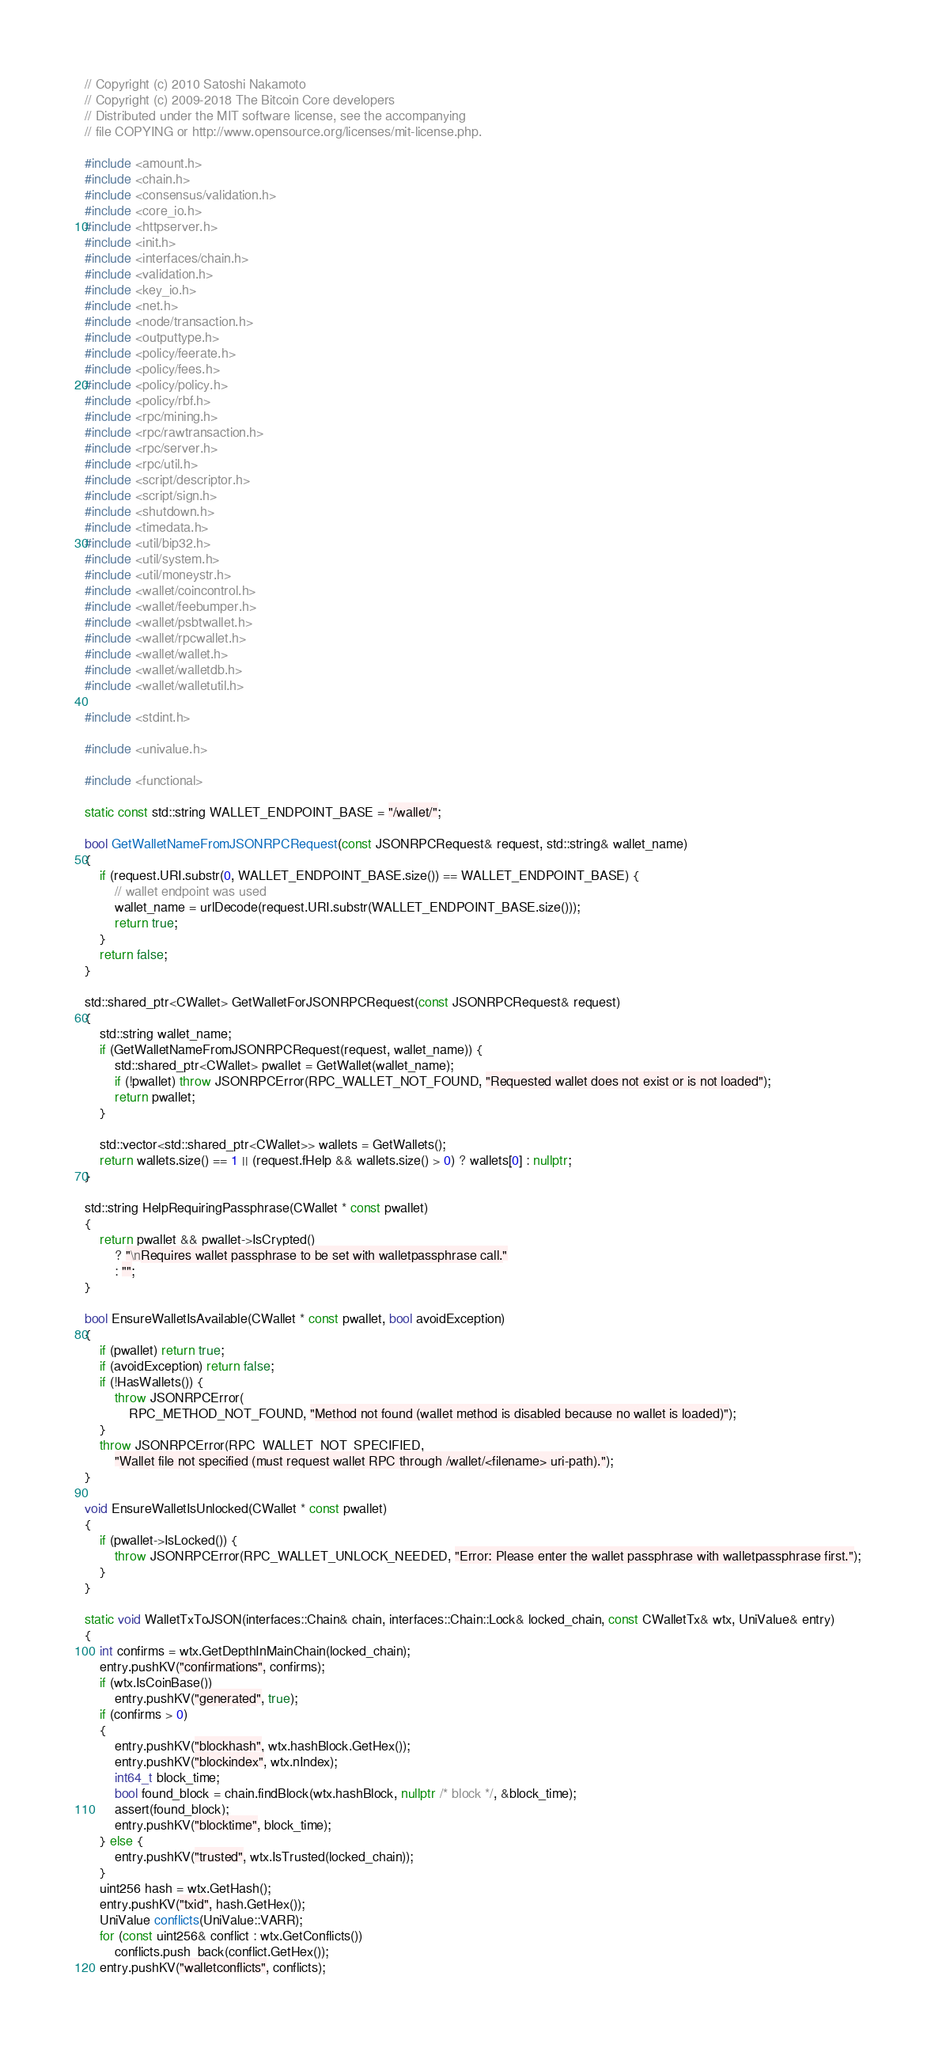Convert code to text. <code><loc_0><loc_0><loc_500><loc_500><_C++_>// Copyright (c) 2010 Satoshi Nakamoto
// Copyright (c) 2009-2018 The Bitcoin Core developers
// Distributed under the MIT software license, see the accompanying
// file COPYING or http://www.opensource.org/licenses/mit-license.php.

#include <amount.h>
#include <chain.h>
#include <consensus/validation.h>
#include <core_io.h>
#include <httpserver.h>
#include <init.h>
#include <interfaces/chain.h>
#include <validation.h>
#include <key_io.h>
#include <net.h>
#include <node/transaction.h>
#include <outputtype.h>
#include <policy/feerate.h>
#include <policy/fees.h>
#include <policy/policy.h>
#include <policy/rbf.h>
#include <rpc/mining.h>
#include <rpc/rawtransaction.h>
#include <rpc/server.h>
#include <rpc/util.h>
#include <script/descriptor.h>
#include <script/sign.h>
#include <shutdown.h>
#include <timedata.h>
#include <util/bip32.h>
#include <util/system.h>
#include <util/moneystr.h>
#include <wallet/coincontrol.h>
#include <wallet/feebumper.h>
#include <wallet/psbtwallet.h>
#include <wallet/rpcwallet.h>
#include <wallet/wallet.h>
#include <wallet/walletdb.h>
#include <wallet/walletutil.h>

#include <stdint.h>

#include <univalue.h>

#include <functional>

static const std::string WALLET_ENDPOINT_BASE = "/wallet/";

bool GetWalletNameFromJSONRPCRequest(const JSONRPCRequest& request, std::string& wallet_name)
{
    if (request.URI.substr(0, WALLET_ENDPOINT_BASE.size()) == WALLET_ENDPOINT_BASE) {
        // wallet endpoint was used
        wallet_name = urlDecode(request.URI.substr(WALLET_ENDPOINT_BASE.size()));
        return true;
    }
    return false;
}

std::shared_ptr<CWallet> GetWalletForJSONRPCRequest(const JSONRPCRequest& request)
{
    std::string wallet_name;
    if (GetWalletNameFromJSONRPCRequest(request, wallet_name)) {
        std::shared_ptr<CWallet> pwallet = GetWallet(wallet_name);
        if (!pwallet) throw JSONRPCError(RPC_WALLET_NOT_FOUND, "Requested wallet does not exist or is not loaded");
        return pwallet;
    }

    std::vector<std::shared_ptr<CWallet>> wallets = GetWallets();
    return wallets.size() == 1 || (request.fHelp && wallets.size() > 0) ? wallets[0] : nullptr;
}

std::string HelpRequiringPassphrase(CWallet * const pwallet)
{
    return pwallet && pwallet->IsCrypted()
        ? "\nRequires wallet passphrase to be set with walletpassphrase call."
        : "";
}

bool EnsureWalletIsAvailable(CWallet * const pwallet, bool avoidException)
{
    if (pwallet) return true;
    if (avoidException) return false;
    if (!HasWallets()) {
        throw JSONRPCError(
            RPC_METHOD_NOT_FOUND, "Method not found (wallet method is disabled because no wallet is loaded)");
    }
    throw JSONRPCError(RPC_WALLET_NOT_SPECIFIED,
        "Wallet file not specified (must request wallet RPC through /wallet/<filename> uri-path).");
}

void EnsureWalletIsUnlocked(CWallet * const pwallet)
{
    if (pwallet->IsLocked()) {
        throw JSONRPCError(RPC_WALLET_UNLOCK_NEEDED, "Error: Please enter the wallet passphrase with walletpassphrase first.");
    }
}

static void WalletTxToJSON(interfaces::Chain& chain, interfaces::Chain::Lock& locked_chain, const CWalletTx& wtx, UniValue& entry)
{
    int confirms = wtx.GetDepthInMainChain(locked_chain);
    entry.pushKV("confirmations", confirms);
    if (wtx.IsCoinBase())
        entry.pushKV("generated", true);
    if (confirms > 0)
    {
        entry.pushKV("blockhash", wtx.hashBlock.GetHex());
        entry.pushKV("blockindex", wtx.nIndex);
        int64_t block_time;
        bool found_block = chain.findBlock(wtx.hashBlock, nullptr /* block */, &block_time);
        assert(found_block);
        entry.pushKV("blocktime", block_time);
    } else {
        entry.pushKV("trusted", wtx.IsTrusted(locked_chain));
    }
    uint256 hash = wtx.GetHash();
    entry.pushKV("txid", hash.GetHex());
    UniValue conflicts(UniValue::VARR);
    for (const uint256& conflict : wtx.GetConflicts())
        conflicts.push_back(conflict.GetHex());
    entry.pushKV("walletconflicts", conflicts);</code> 